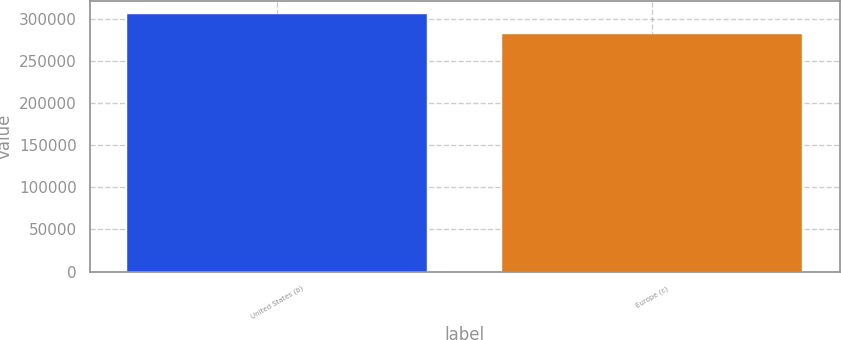<chart> <loc_0><loc_0><loc_500><loc_500><bar_chart><fcel>United States (b)<fcel>Europe (c)<nl><fcel>305852<fcel>281844<nl></chart> 